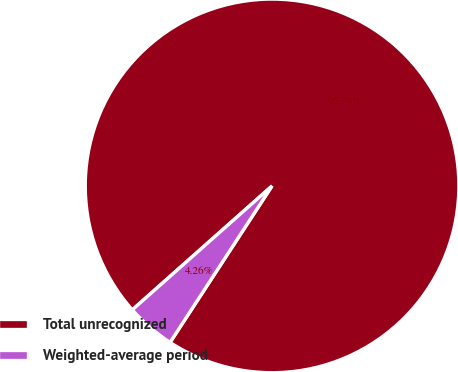Convert chart. <chart><loc_0><loc_0><loc_500><loc_500><pie_chart><fcel>Total unrecognized<fcel>Weighted-average period<nl><fcel>95.74%<fcel>4.26%<nl></chart> 